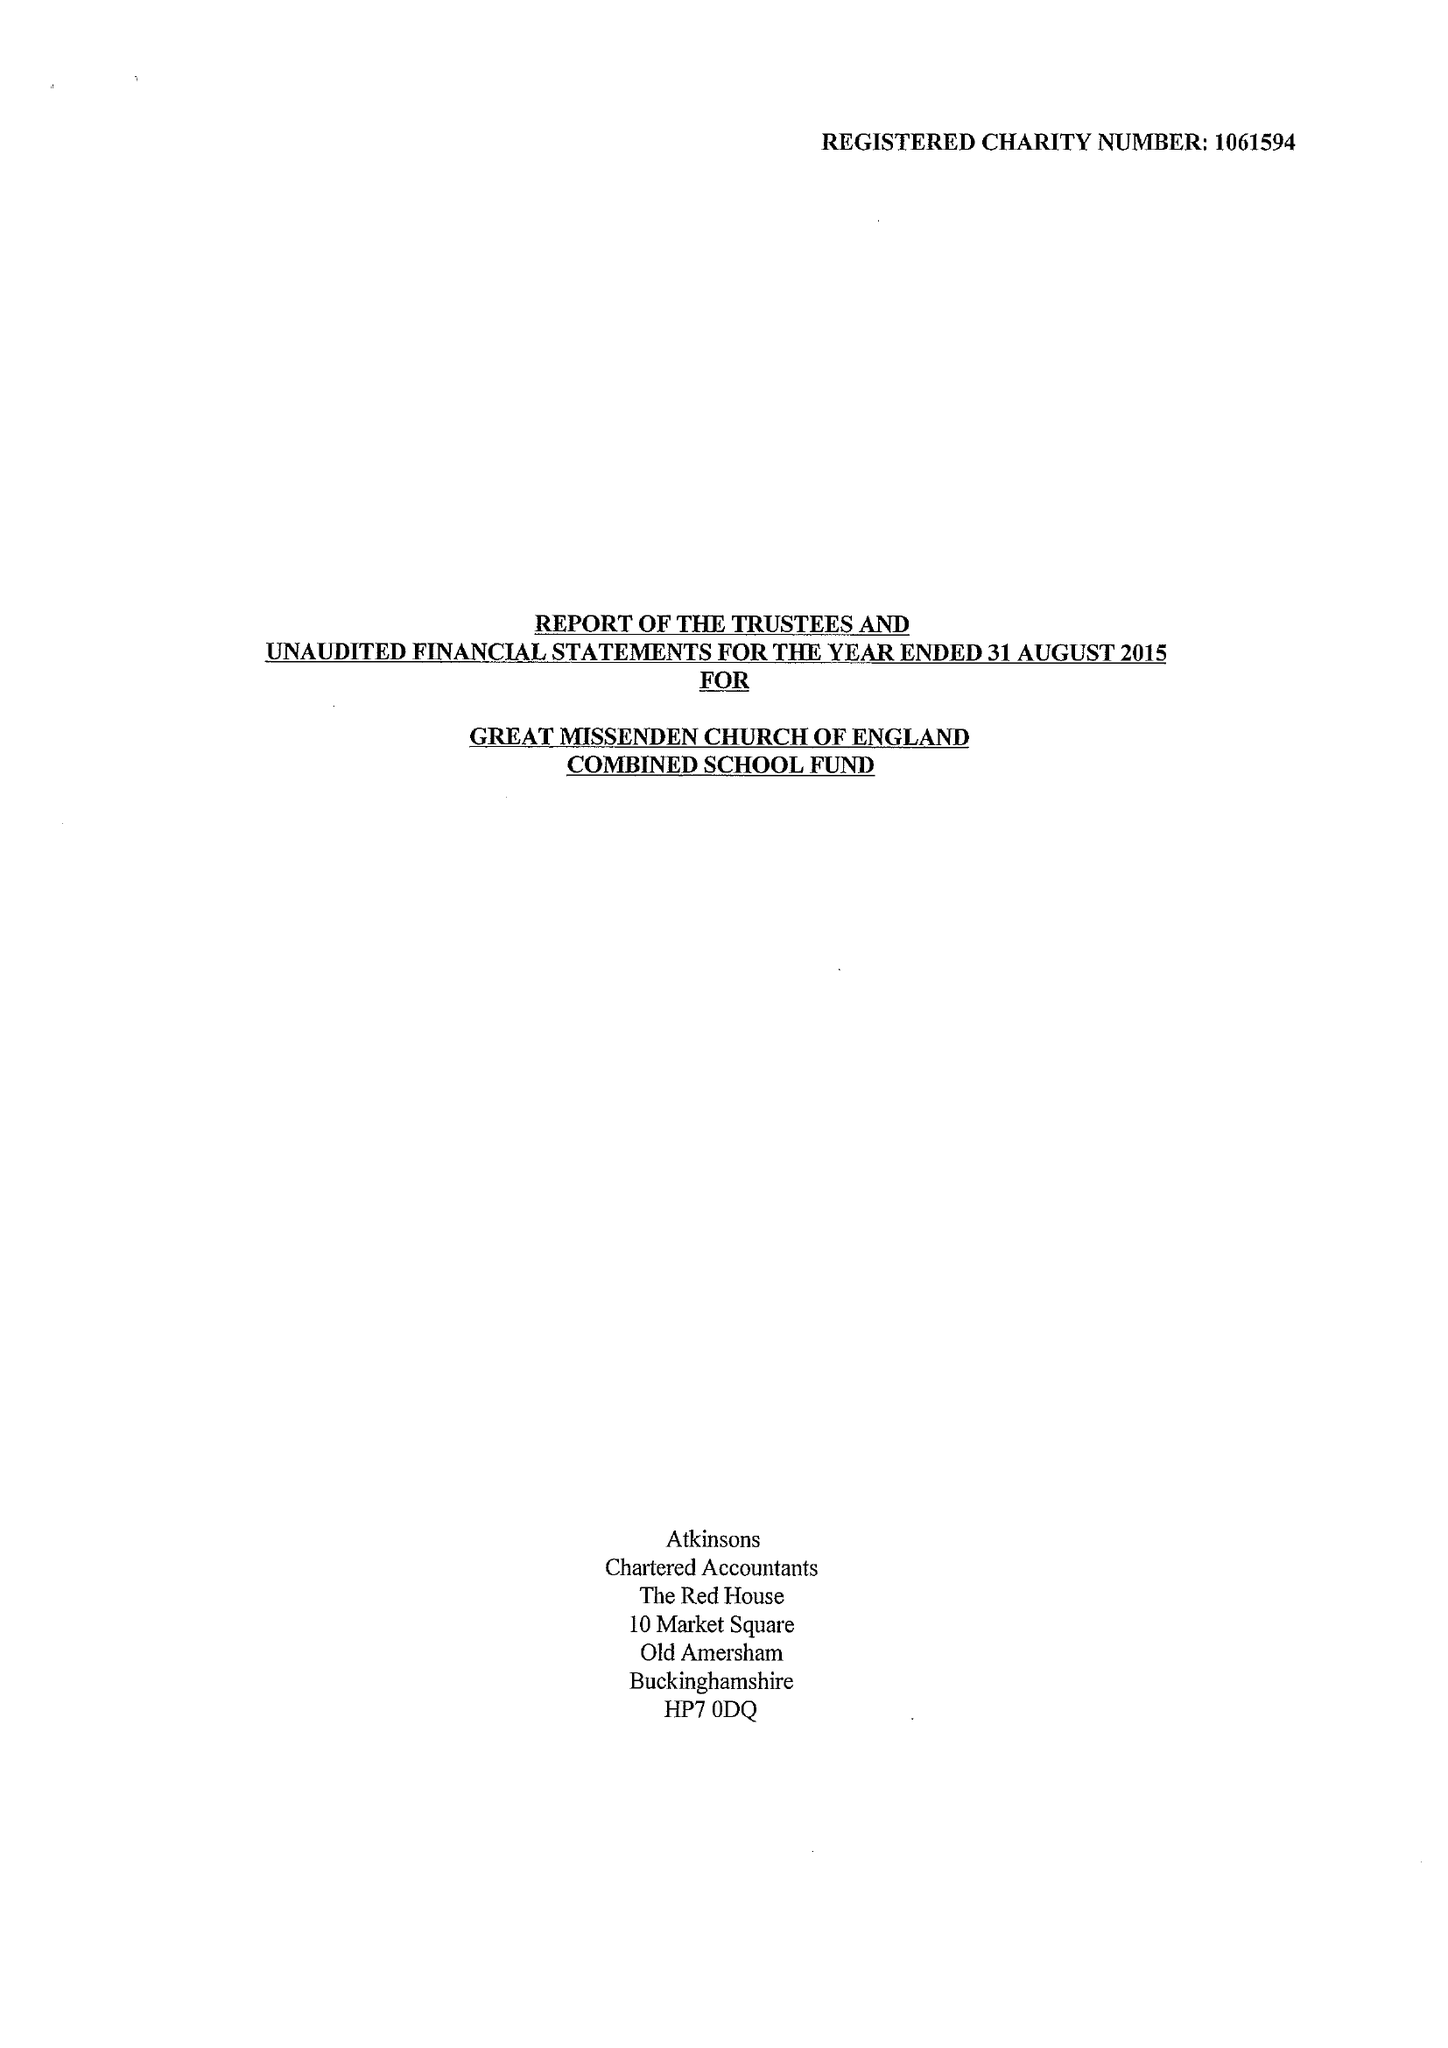What is the value for the charity_number?
Answer the question using a single word or phrase. 1061594 